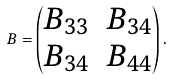<formula> <loc_0><loc_0><loc_500><loc_500>B = \begin{pmatrix} B _ { 3 3 } & B _ { 3 4 } \\ B _ { 3 4 } & B _ { 4 4 } \end{pmatrix} .</formula> 